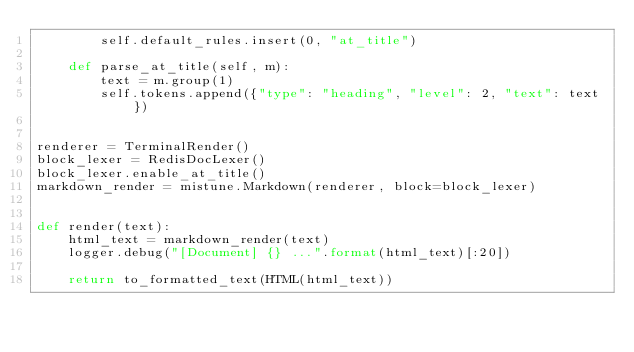Convert code to text. <code><loc_0><loc_0><loc_500><loc_500><_Python_>        self.default_rules.insert(0, "at_title")

    def parse_at_title(self, m):
        text = m.group(1)
        self.tokens.append({"type": "heading", "level": 2, "text": text})


renderer = TerminalRender()
block_lexer = RedisDocLexer()
block_lexer.enable_at_title()
markdown_render = mistune.Markdown(renderer, block=block_lexer)


def render(text):
    html_text = markdown_render(text)
    logger.debug("[Document] {} ...".format(html_text)[:20])

    return to_formatted_text(HTML(html_text))
</code> 